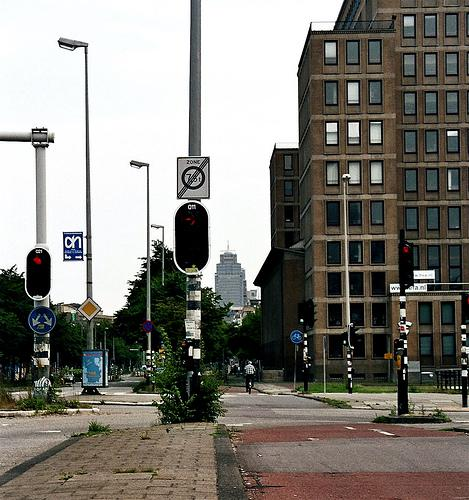Question: what color are the tall buildings on the right?
Choices:
A. Brown.
B. Yellow.
C. Grey.
D. White.
Answer with the letter. Answer: A Question: what color are the traffic lights?
Choices:
A. Green.
B. Red.
C. Yellow.
D. Orange.
Answer with the letter. Answer: B Question: where is the yellow diamond sign?
Choices:
A. Behind the woman.
B. To the right of the cars.
C. Under the parking sign.
D. Left, near the left-most traffic light.
Answer with the letter. Answer: D Question: what color is the sky?
Choices:
A. Blue.
B. Aqua.
C. Green.
D. Grey.
Answer with the letter. Answer: D Question: how many traffic lights are visible?
Choices:
A. Three.
B. Four.
C. Six.
D. Five.
Answer with the letter. Answer: B Question: how many windows are in a row on the left building?
Choices:
A. Ten.
B. Four.
C. Five.
D. Three.
Answer with the letter. Answer: D 